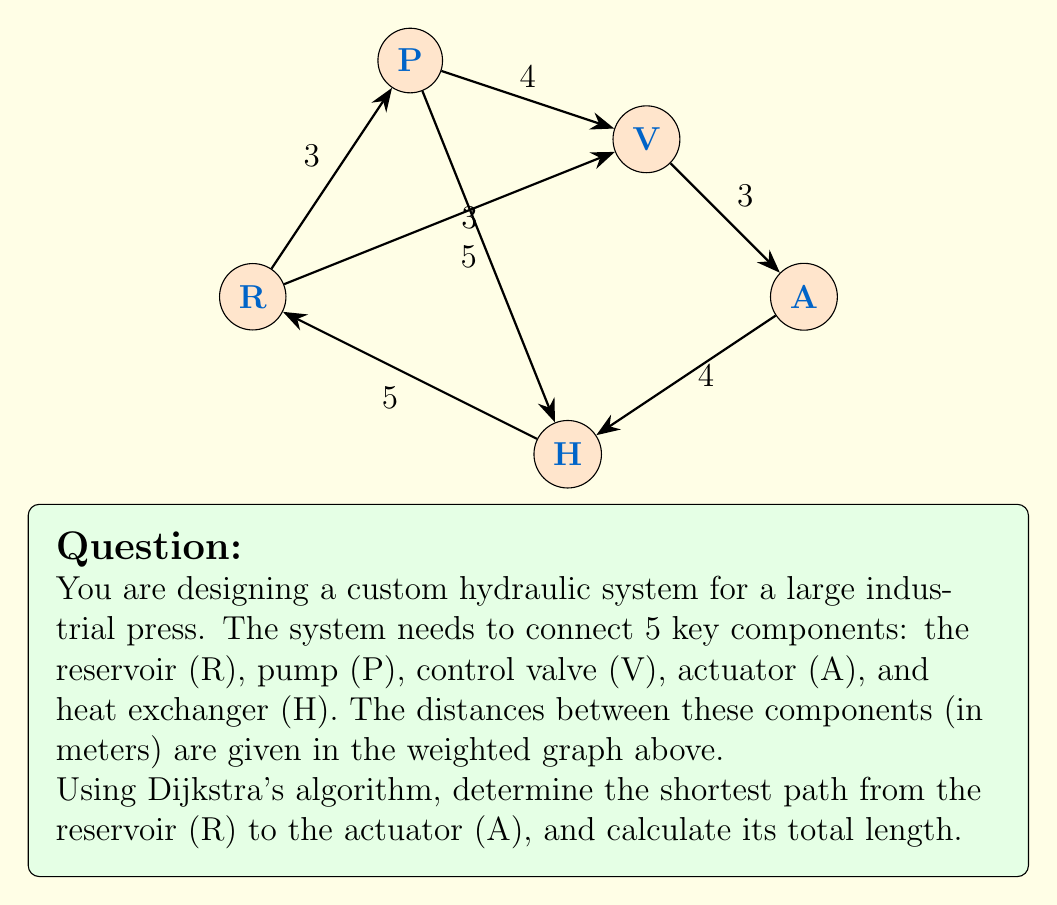Show me your answer to this math problem. To solve this problem, we'll apply Dijkstra's algorithm to find the shortest path from R to A. Here's a step-by-step explanation:

1) Initialize:
   - Set distance to R as 0, and all other nodes as infinity.
   - Set R as the current node.
   - Unvisited set: {R, P, V, H, A}

2) From R:
   - Update distances: P(3), V(3), H(5)
   - Mark R as visited
   - Unvisited set: {P, V, H, A}
   - Current node: P (closest unvisited)

3) From P:
   - Update distances: V(min(3, 3+4)=3), H(min(5, 3+5)=5)
   - Mark P as visited
   - Unvisited set: {V, H, A}
   - Current node: V (closest unvisited)

4) From V:
   - Update distances: A(3+3=6), H(min(5, 3+3)=5)
   - Mark V as visited
   - Unvisited set: {H, A}
   - Current node: H (closest unvisited)

5) From H:
   - Update distances: A(min(6, 5+4)=6)
   - Mark H as visited
   - Unvisited set: {A}
   - Current node: A (only remaining)

6) Algorithm terminates as we've reached A.

The shortest path is R → V → A, with a total length of 6 meters.
Answer: The shortest path from R to A is R → V → A, with a total length of 6 meters. 